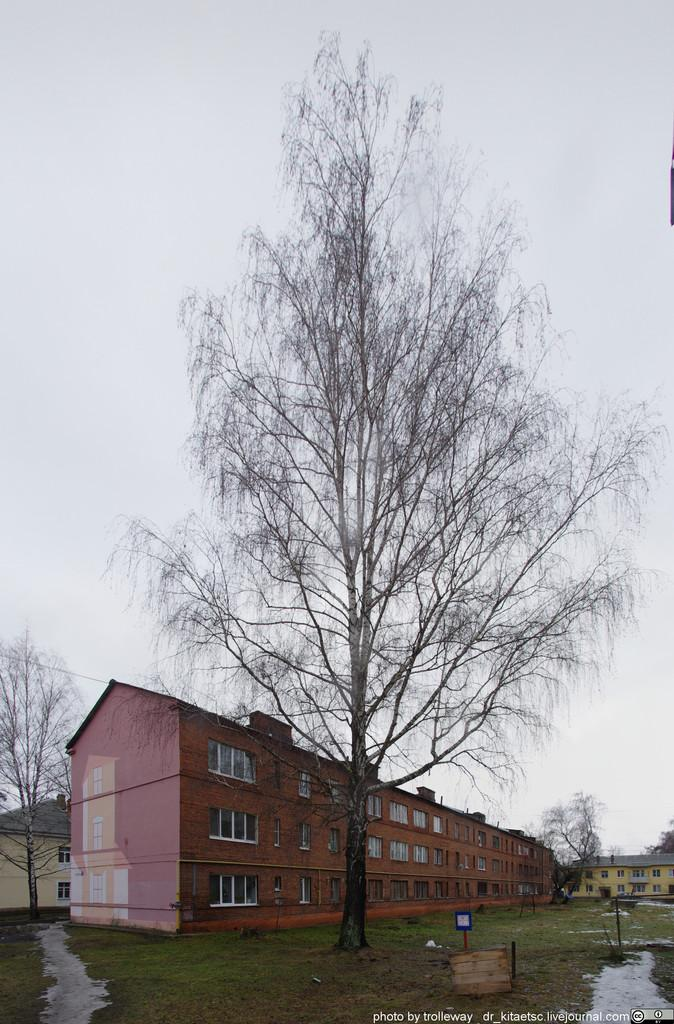What type of structures can be seen in the image? There are houses in the image. What covers the ground in the image? The ground is covered with grass. What else can be found on the ground in the image? There are objects visible on the ground. What type of vegetation is present in the image? There are trees in the image. What is the flat, rectangular object in the image? There is a board in the image. What is visible above the structures and vegetation in the image? The sky is visible in the image. How many eyes can be seen on the trees in the image? Trees do not have eyes, so this question cannot be answered. What type of quartz is present on the ground in the image? There is no mention of quartz in the image, so this question cannot be answered. 